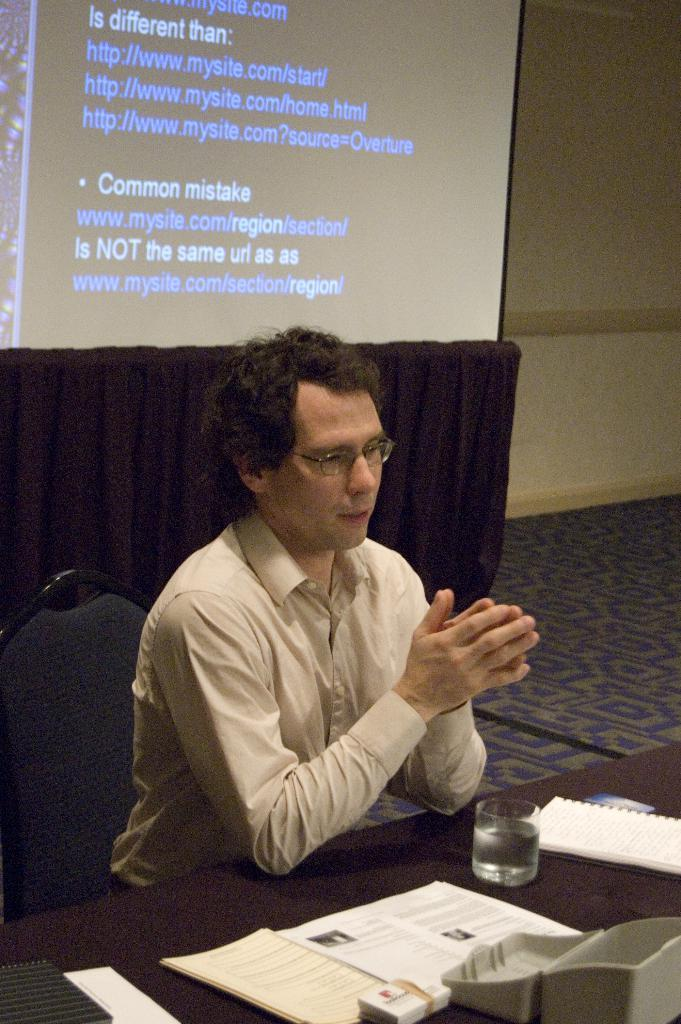What is the man in the image doing? The man is seated in the image. What is the man sitting on? The man is seated on a chair. What objects are on the table in the image? There are papers and a cup of water on the table. What is on the wall in the image? There is a projector screen on the wall. What type of vegetable is being used as a decoration on the street in the image? There is no vegetable or street present in the image; it features a man seated on a chair with a table and a projector screen on the wall. 